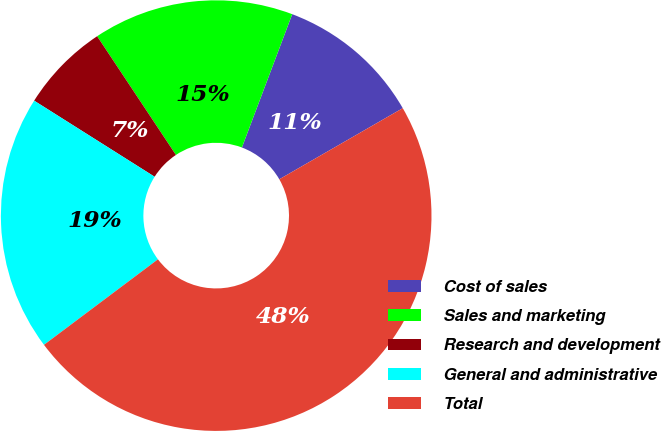Convert chart to OTSL. <chart><loc_0><loc_0><loc_500><loc_500><pie_chart><fcel>Cost of sales<fcel>Sales and marketing<fcel>Research and development<fcel>General and administrative<fcel>Total<nl><fcel>10.94%<fcel>15.07%<fcel>6.71%<fcel>19.21%<fcel>48.07%<nl></chart> 